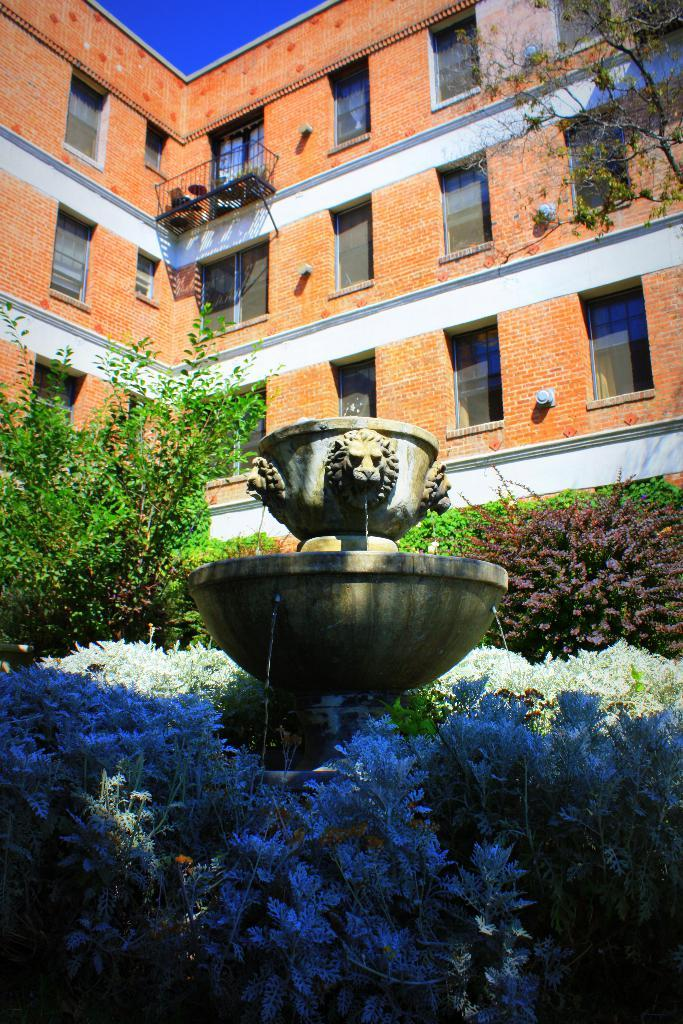What type of structure is visible in the image? There is a building in the image. What else can be seen in the image besides the building? There are many plants and a fountain in the image. Where is the kitten sitting on the table in the image? There is no table or kitten present in the image. 